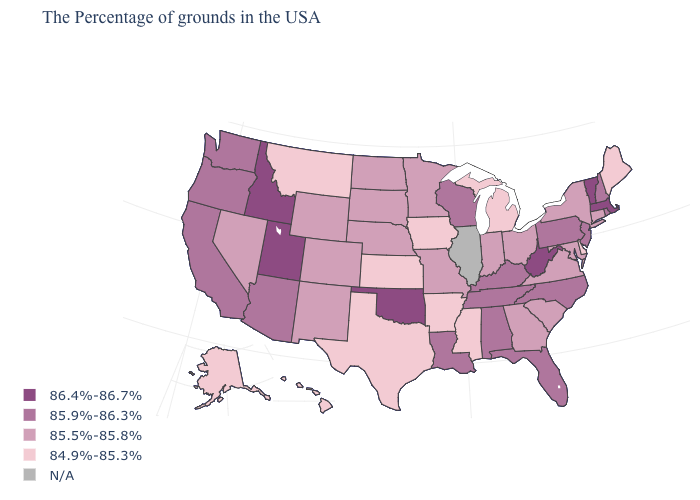Which states have the lowest value in the West?
Short answer required. Montana, Alaska, Hawaii. What is the value of South Dakota?
Write a very short answer. 85.5%-85.8%. Name the states that have a value in the range 84.9%-85.3%?
Give a very brief answer. Maine, Delaware, Michigan, Mississippi, Arkansas, Iowa, Kansas, Texas, Montana, Alaska, Hawaii. What is the value of Oklahoma?
Quick response, please. 86.4%-86.7%. Does Maryland have the lowest value in the South?
Give a very brief answer. No. What is the value of Alaska?
Answer briefly. 84.9%-85.3%. Which states have the highest value in the USA?
Be succinct. Massachusetts, Vermont, West Virginia, Oklahoma, Utah, Idaho. Name the states that have a value in the range 85.9%-86.3%?
Concise answer only. Rhode Island, New Hampshire, New Jersey, Pennsylvania, North Carolina, Florida, Kentucky, Alabama, Tennessee, Wisconsin, Louisiana, Arizona, California, Washington, Oregon. What is the value of North Carolina?
Concise answer only. 85.9%-86.3%. Which states have the lowest value in the West?
Keep it brief. Montana, Alaska, Hawaii. Which states have the lowest value in the South?
Concise answer only. Delaware, Mississippi, Arkansas, Texas. 